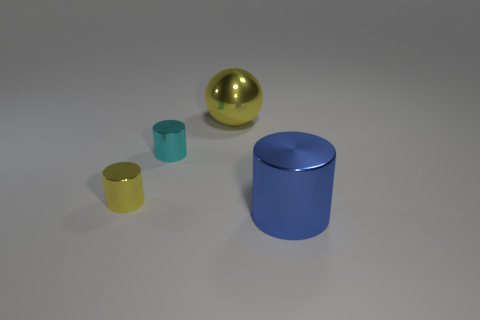Can you describe the lighting in the scene? The lighting in the scene appears to be soft and diffused, with gentle shadows indicating a light source coming from above, perhaps simulating an overcast sky or indoor lighting without strong direct light. 